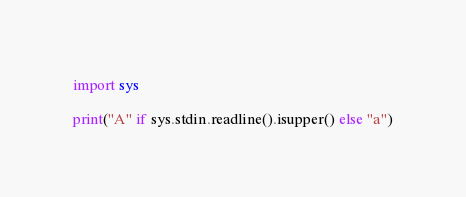Convert code to text. <code><loc_0><loc_0><loc_500><loc_500><_Python_>import sys

print("A" if sys.stdin.readline().isupper() else "a")
</code> 